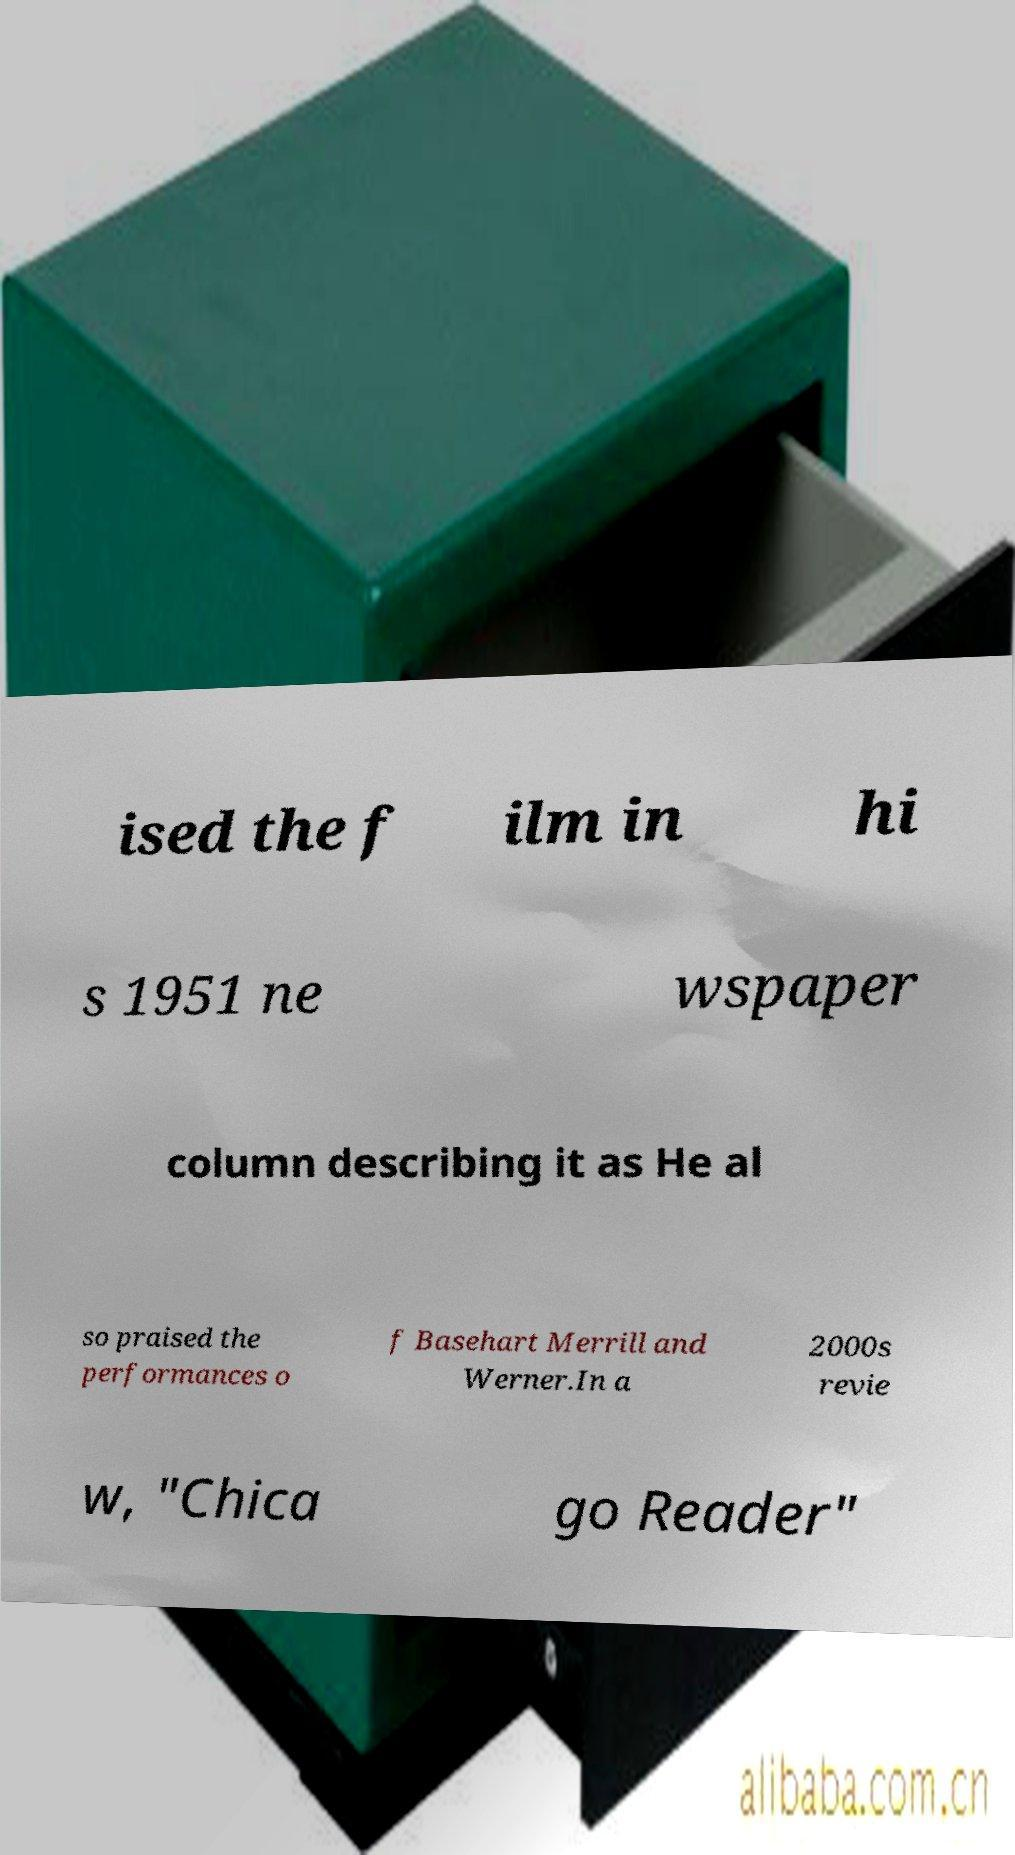Please identify and transcribe the text found in this image. ised the f ilm in hi s 1951 ne wspaper column describing it as He al so praised the performances o f Basehart Merrill and Werner.In a 2000s revie w, "Chica go Reader" 